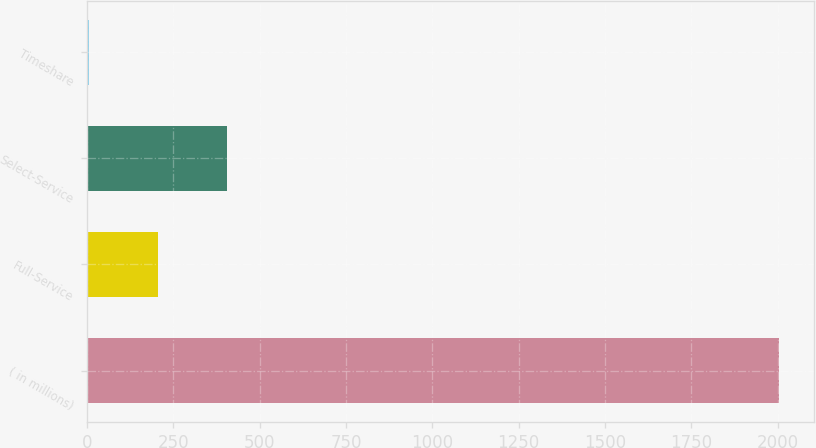<chart> <loc_0><loc_0><loc_500><loc_500><bar_chart><fcel>( in millions)<fcel>Full-Service<fcel>Select-Service<fcel>Timeshare<nl><fcel>2004<fcel>206.7<fcel>406.4<fcel>7<nl></chart> 